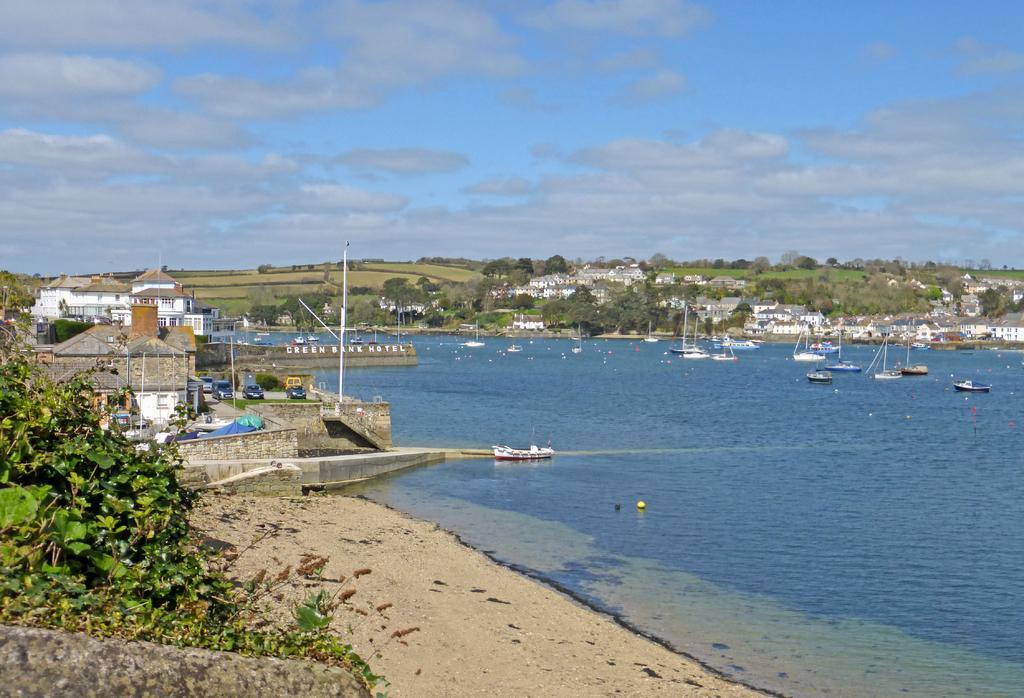In one or two sentences, can you explain what this image depicts? In this image, there are a few buildings, vehicles, poles, trees, plants. We can also see some water with boats sailing on it. We can also see some grass and the sky with clouds. 